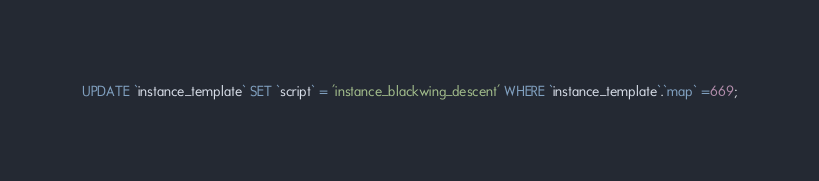<code> <loc_0><loc_0><loc_500><loc_500><_SQL_>UPDATE `instance_template` SET `script` = 'instance_blackwing_descent' WHERE `instance_template`.`map` =669;</code> 